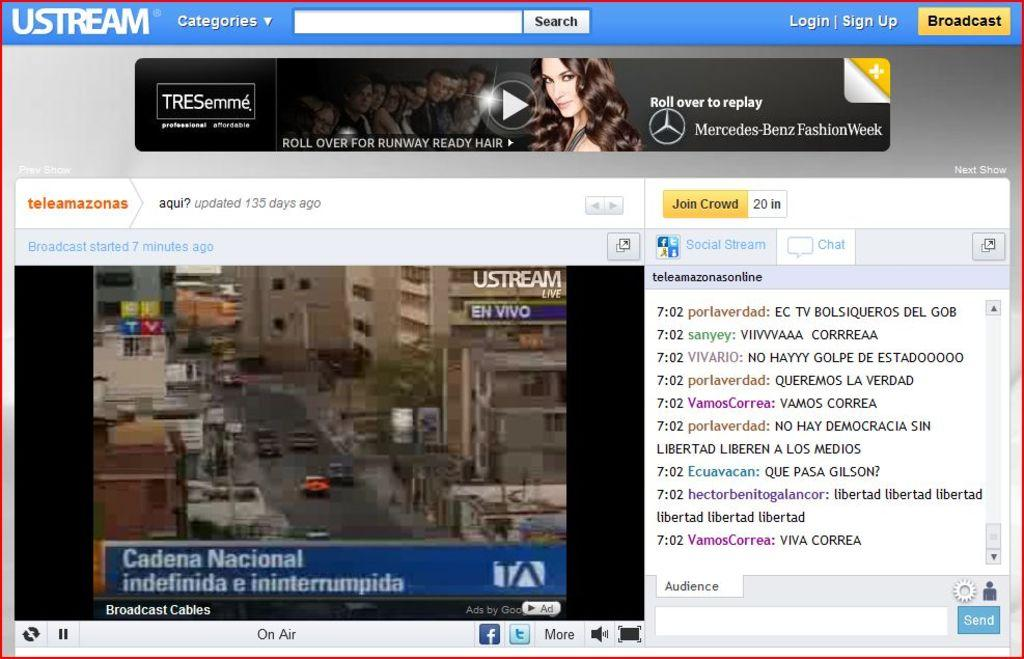What can be seen moving on the road in the image? There are vehicles on the road in the image. What type of structures are visible in the image? There are buildings in the image. What type of natural elements can be seen in the image? There are trees in the image. What type of living beings are present in the image? There are people in the image. What type of signs or markings can be seen in the image? There are symbols in the image. What type of physical objects are present in the image? There are objects in the image. What type of written communication can be seen in the image? There is text in the image. Where is the garden located in the image? There is no garden present in the image. What type of emotion is being expressed by the love in the image? There is no love or emotion present in the image. 